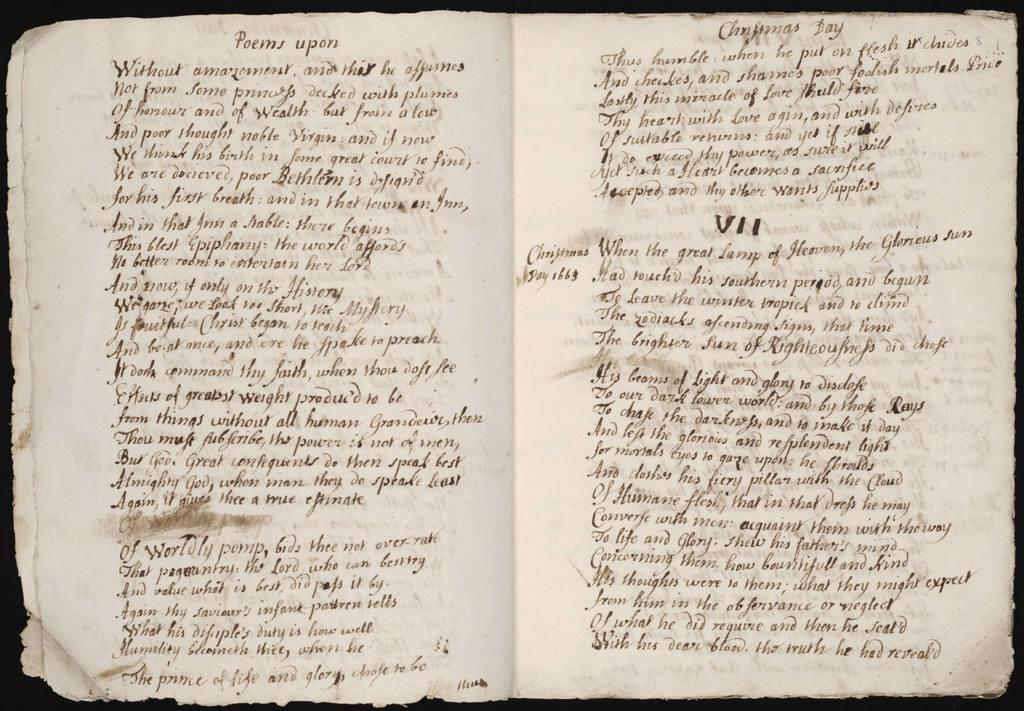<image>
Summarize the visual content of the image. a book in old fashioned writing with the words Poems upon written at the top 